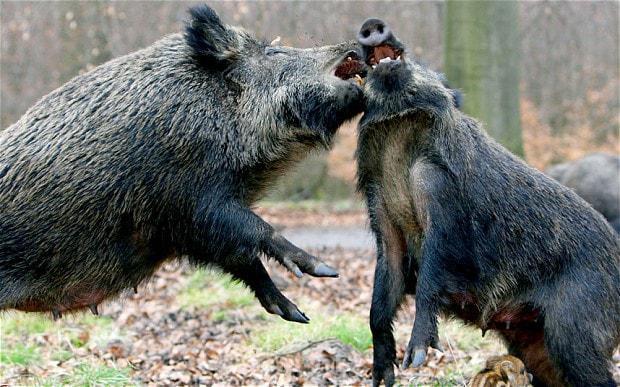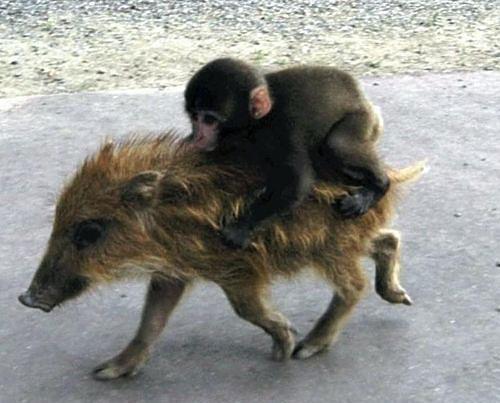The first image is the image on the left, the second image is the image on the right. Considering the images on both sides, is "The left image contains exactly one wild boar." valid? Answer yes or no. No. The first image is the image on the left, the second image is the image on the right. For the images displayed, is the sentence "There is more than one animal species in the image." factually correct? Answer yes or no. Yes. 